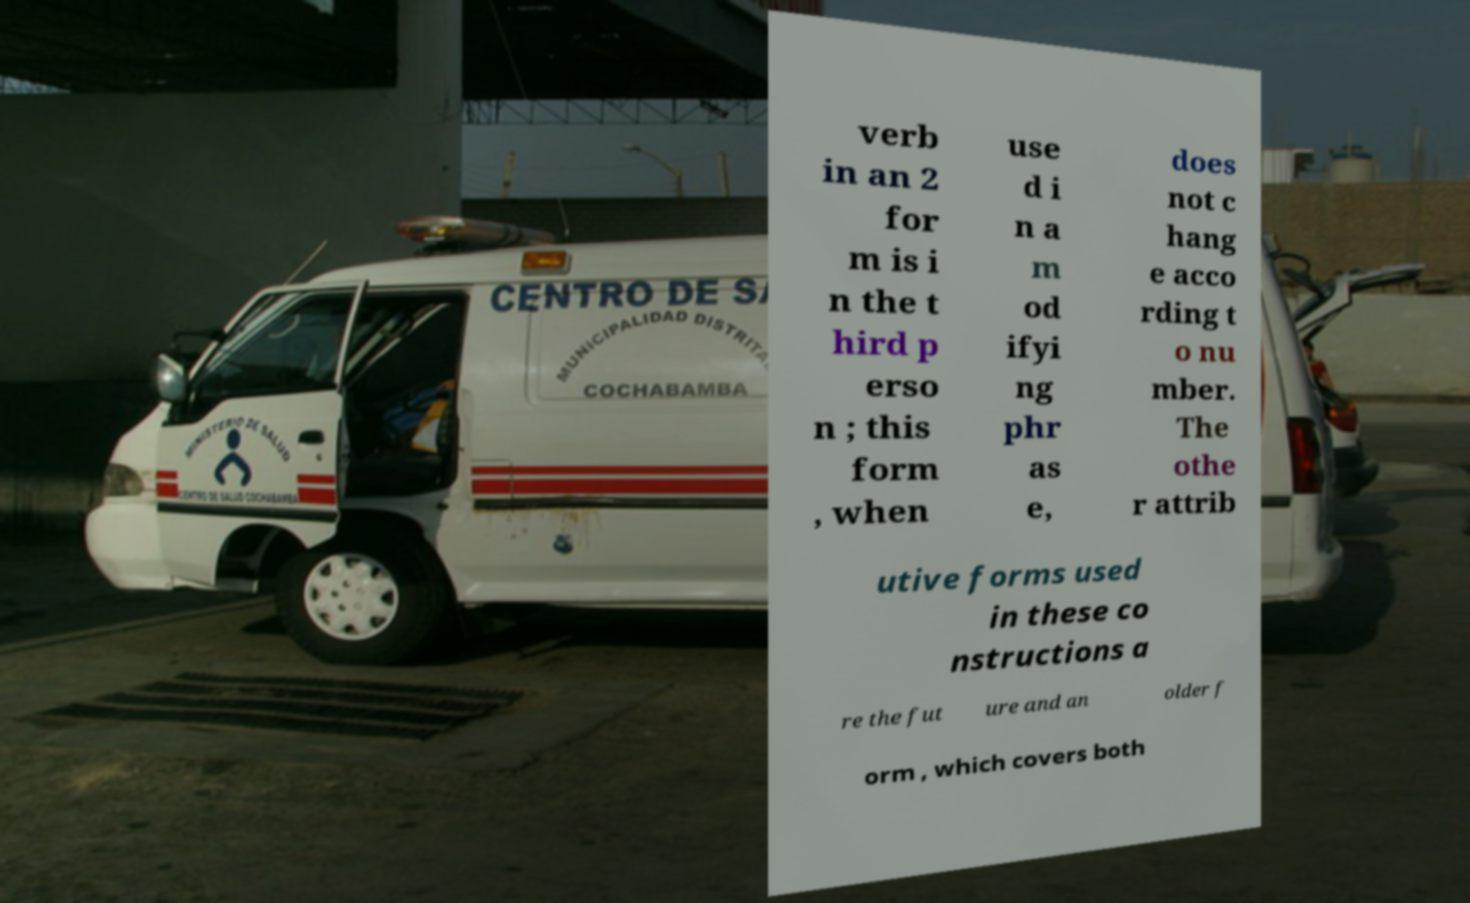For documentation purposes, I need the text within this image transcribed. Could you provide that? verb in an 2 for m is i n the t hird p erso n ; this form , when use d i n a m od ifyi ng phr as e, does not c hang e acco rding t o nu mber. The othe r attrib utive forms used in these co nstructions a re the fut ure and an older f orm , which covers both 